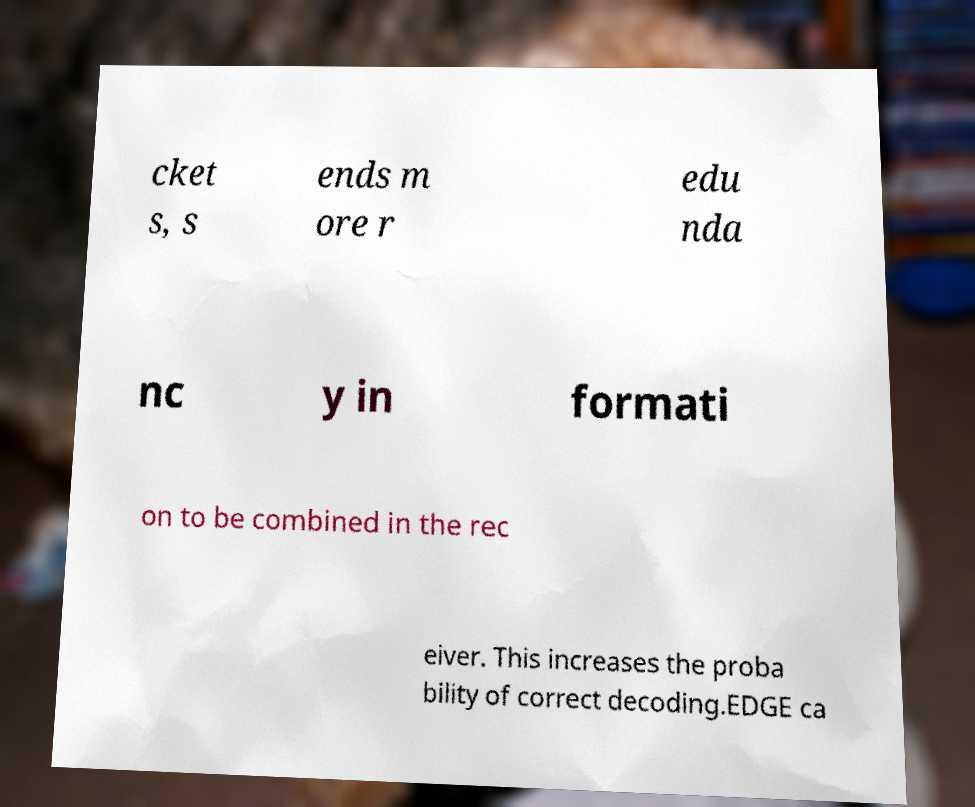I need the written content from this picture converted into text. Can you do that? cket s, s ends m ore r edu nda nc y in formati on to be combined in the rec eiver. This increases the proba bility of correct decoding.EDGE ca 